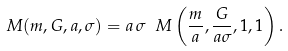<formula> <loc_0><loc_0><loc_500><loc_500>M ( m , G , a , \sigma ) = a \, \sigma \ M \left ( \frac { m } { a } , \frac { G } { a \sigma } , 1 , 1 \right ) .</formula> 